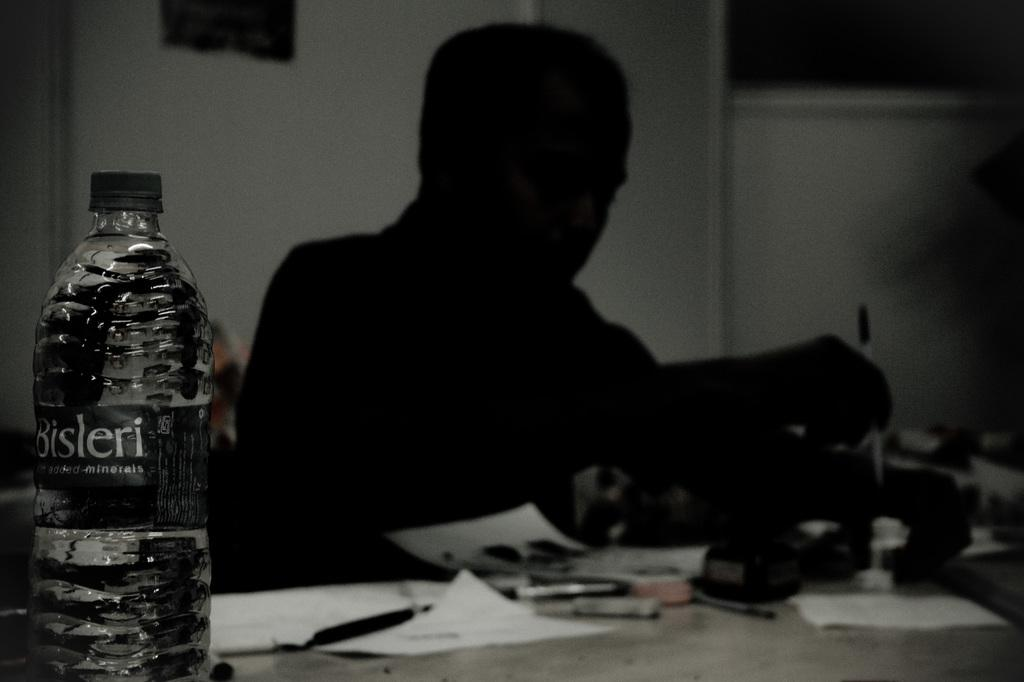What can be seen in the image that is typically used for holding liquids? There is a bottle in the image. Who or what is present in the image along with the bottle? There is a person in the image. What is located in front of the person in the image? There is a paper in front of the person. What can be seen in the image that is commonly used for writing? There is a pen in the image. Are there any other objects present in the image besides the bottle, person, paper, and pen? Yes, there are other objects present in the image. How many birds are flying in the image? There are no birds present in the image. What type of beetle can be seen crawling on the person's shoulder in the image? There is no beetle present on the person's shoulder in the image. 